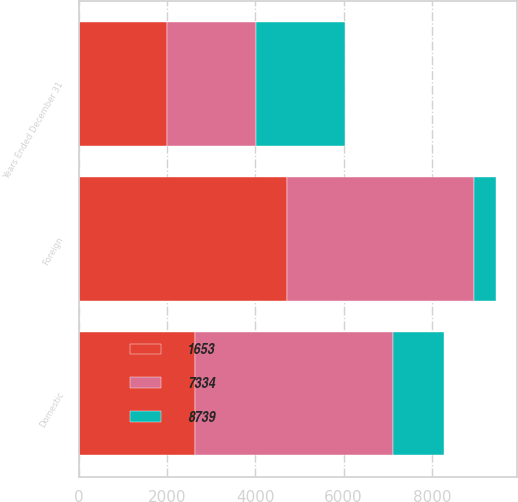Convert chart to OTSL. <chart><loc_0><loc_0><loc_500><loc_500><stacked_bar_chart><ecel><fcel>Years Ended December 31<fcel>Domestic<fcel>Foreign<nl><fcel>7334<fcel>2012<fcel>4500<fcel>4239<nl><fcel>1653<fcel>2011<fcel>2626<fcel>4708<nl><fcel>8739<fcel>2010<fcel>1154<fcel>499<nl></chart> 